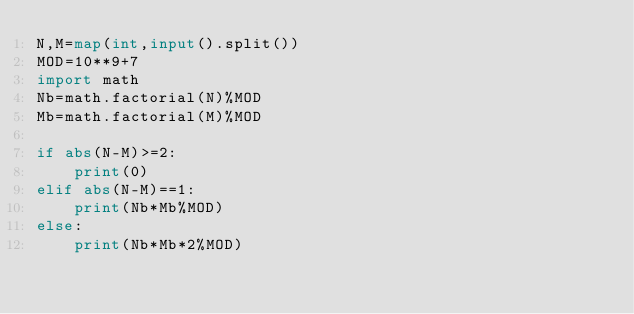<code> <loc_0><loc_0><loc_500><loc_500><_Python_>N,M=map(int,input().split())
MOD=10**9+7
import math
Nb=math.factorial(N)%MOD
Mb=math.factorial(M)%MOD

if abs(N-M)>=2:
    print(0)
elif abs(N-M)==1:
    print(Nb*Mb%MOD)
else:
    print(Nb*Mb*2%MOD)</code> 